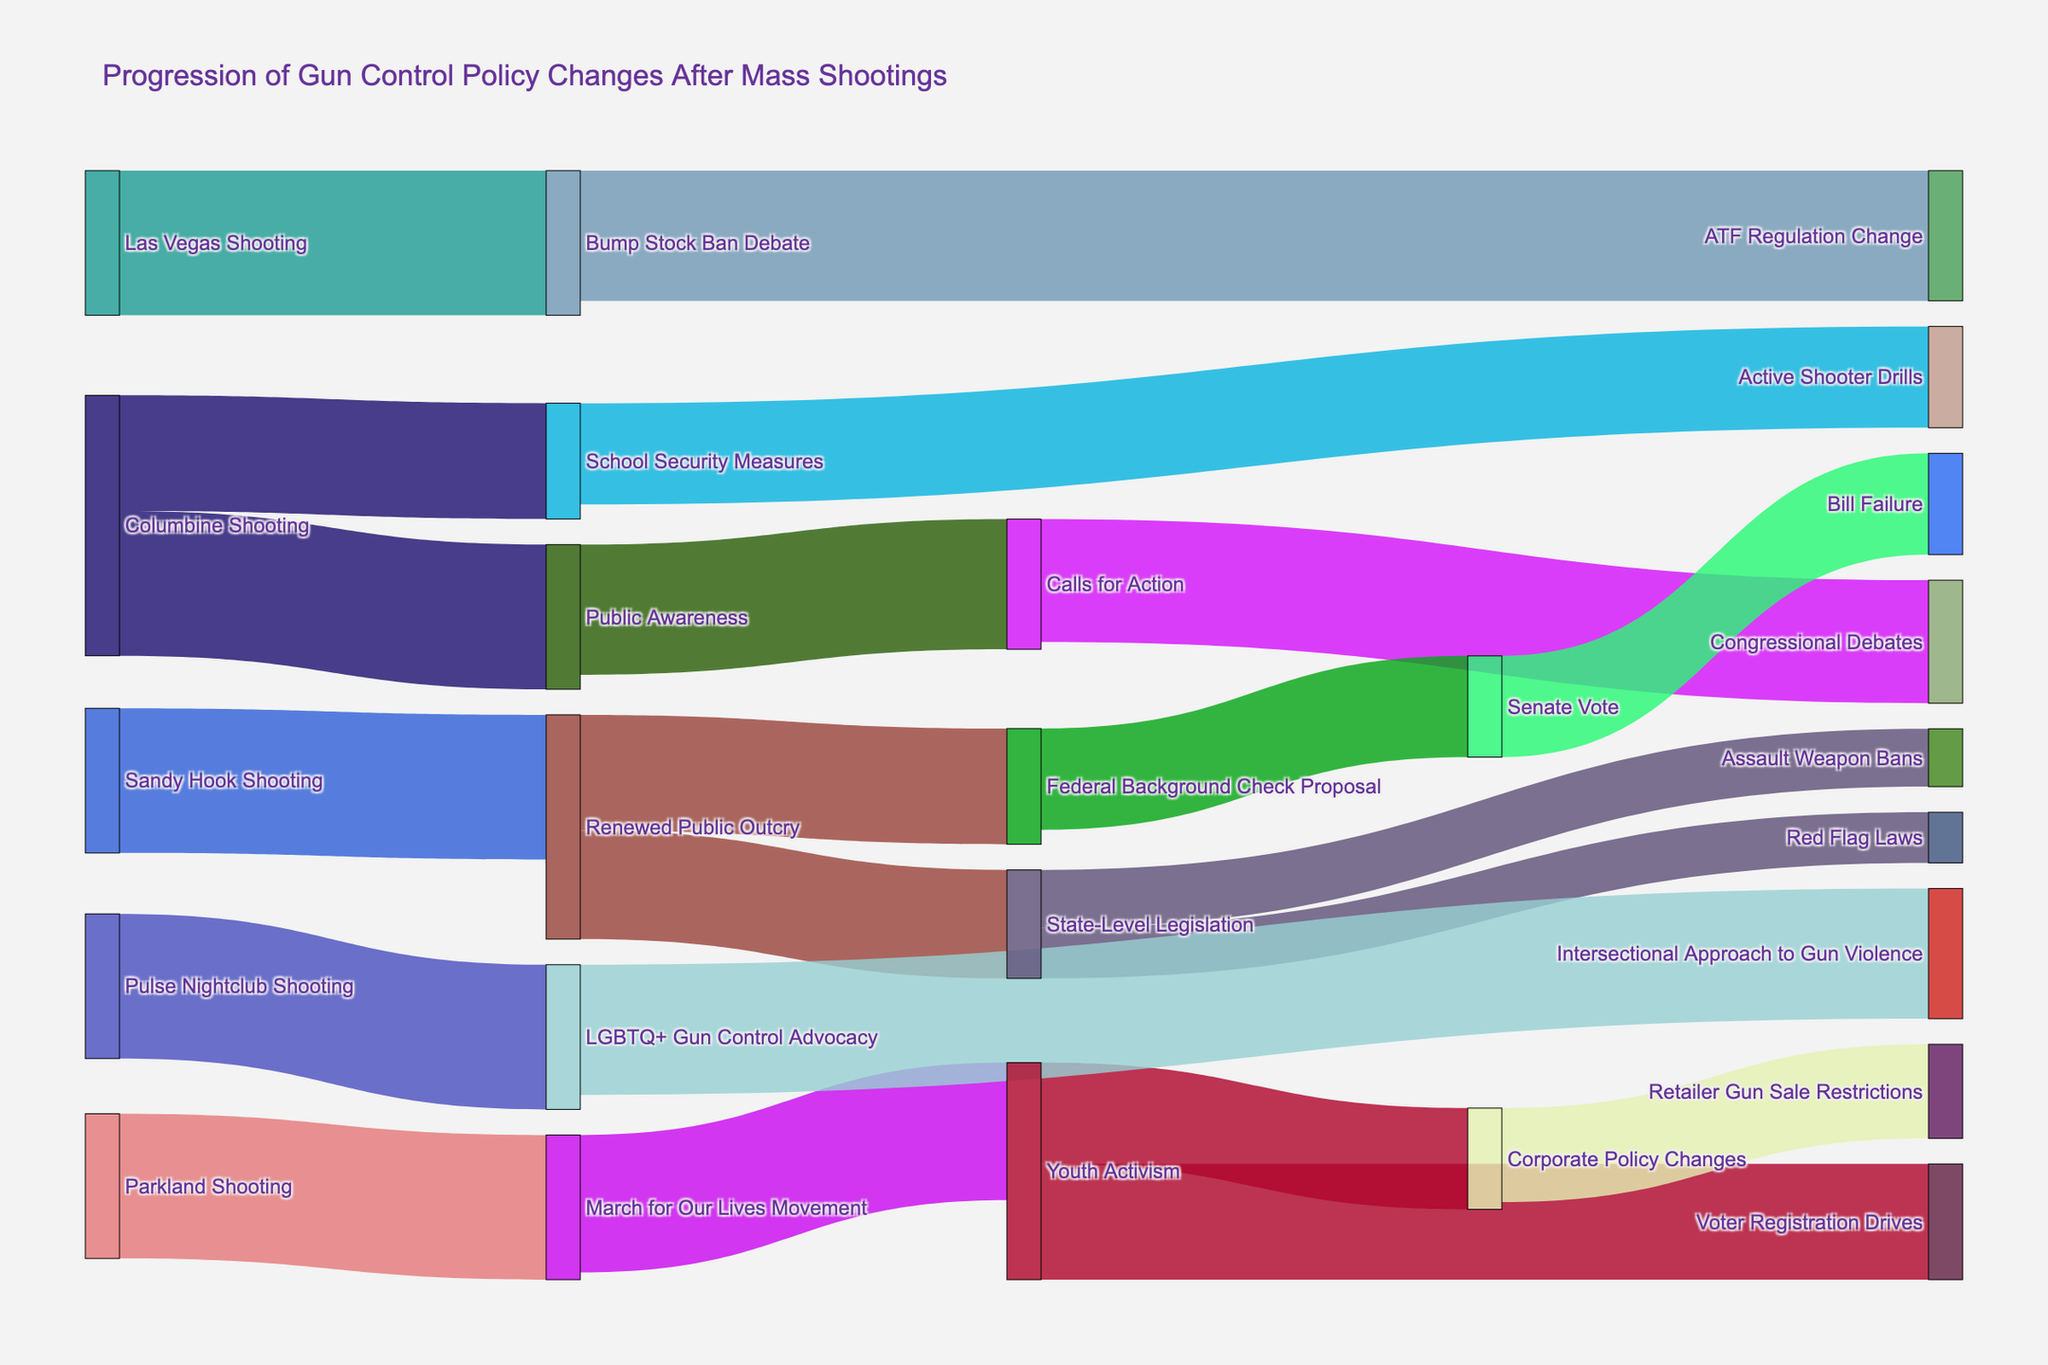What is the title of the figure? The title is usually prominently displayed at the top of the diagram. By looking at the top of the figure, we can read the full title.
Answer: Progression of Gun Control Policy Changes After Mass Shootings How many connections are there stemming from the Columbine Shooting? Identify the connections (or links) that originate specifically from the "Columbine Shooting" node. Count them to find the answer.
Answer: 2 Which shooting incident led to the highest number of direct subsequent actions? Compare the number of direct connections stemming from each major shooting incident node. The node with the highest number of outgoing connections will be the answer.
Answer: Parkland Shooting What is the value of the ATF Regulation Change link, and which incident does it relate to? Locate the "ATF Regulation Change" node and trace back to its source connection to find both its value and related incident.
Answer: The value is 90, and it relates to the Las Vegas Shooting Which policy action received the same value from the State-Level Legislation node? Find the links stemming from the "State-Level Legislation" node and compare their values. Identify the ones with identical values.
Answer: Red Flag Laws and Assault Weapon Bans both received values What sequence of events followed the Sandy Hook Shooting leading to Bill Failure? Start at the "Sandy Hook Shooting" node and follow the pathway through successive policy changes until reaching "Bill Failure." List the events in order.
Answer: Renewed Public Outcry → Federal Background Check Proposal → Senate Vote → Bill Failure Which target received the highest amount of attention or resources from multiple different sources? Look for a target node that has multiple incoming connections and then find out the one with the highest sum of values or the number of connections.
Answer: Public Awareness What was the total value count for the youth-related activities following the Parkland Shooting? Identify all connections stemming from the "March for Our Lives Movement" or related to youth activism, then sum their values.
Answer: 245 Which event has a more significant impact on legislative changes, Sandy Hook or Pulse Nightclub Shooting? Assess the connections coming out from the nodes "Sandy Hook Shooting" and "Pulse Nightclub Shooting," focusing on those that lead directly or indirectly to legislative changes.
Answer: Sandy Hook Shooting Looking at direct policy changes, rank the major shooting incidents based on the number of unique subsequent actions. Count the distinct connections stemming from each shooting incident node and rank them based on the count.
Answer: Parkland Shooting > Sandy Hook Shooting > Pulse Nightclub Shooting = Las Vegas Shooting > Columbine Shooting 